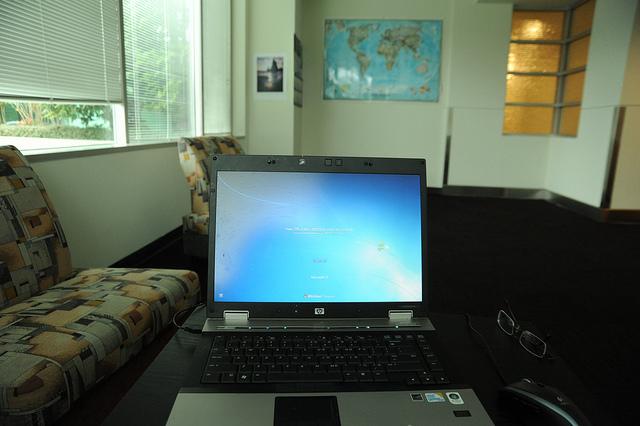Is there a leather couch?
Be succinct. No. What is hanging on the wall?
Short answer required. Map. Is the comp on?
Keep it brief. Yes. How many chairs are there?
Quick response, please. 2. 